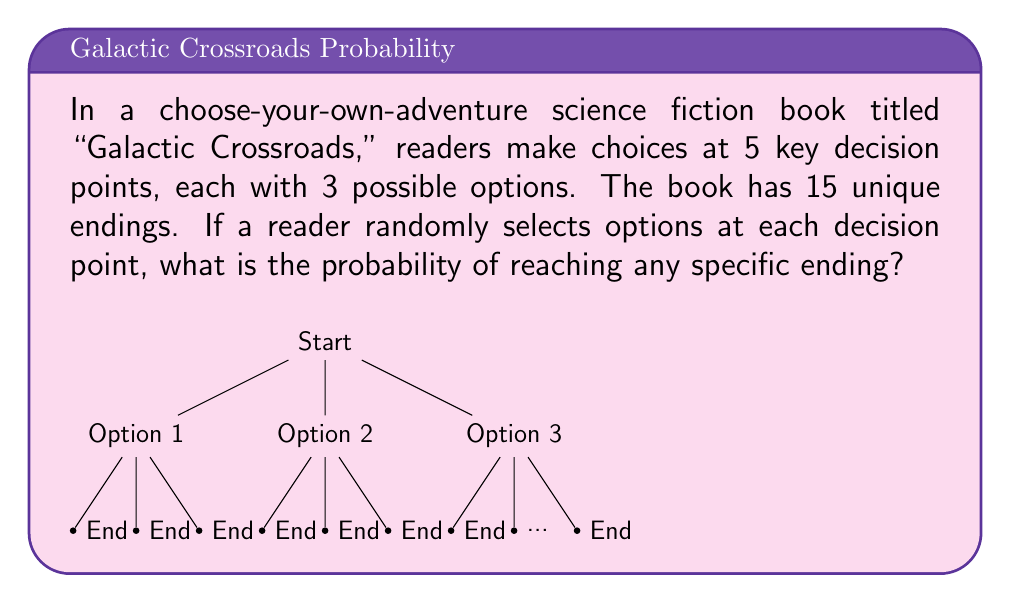Can you answer this question? Let's approach this step-by-step:

1) First, we need to calculate the total number of possible paths through the book:
   - There are 5 decision points, each with 3 options.
   - The total number of paths is therefore $3^5 = 243$.

2) Now, we know that there are 15 unique endings.

3) If all endings were equally likely, each ending would be reached by:
   $\frac{243}{15} = 16.2$ paths

4) However, since we can only have whole numbers of paths, some endings must be reached by 16 paths and others by 17 paths.

5) The probability of reaching any specific ending is the number of paths leading to that ending divided by the total number of paths:

   $$P(\text{specific ending}) = \frac{\text{paths to ending}}{\text{total paths}} = \frac{16 \text{ or } 17}{243}$$

6) To be precise, we can calculate:
   - For endings reached by 16 paths: $P = \frac{16}{243} \approx 0.0658$
   - For endings reached by 17 paths: $P = \frac{17}{243} \approx 0.0700$

Therefore, the probability of reaching any specific ending is either $\frac{16}{243}$ or $\frac{17}{243}$, depending on the specific ending.
Answer: $\frac{16}{243}$ or $\frac{17}{243}$ 